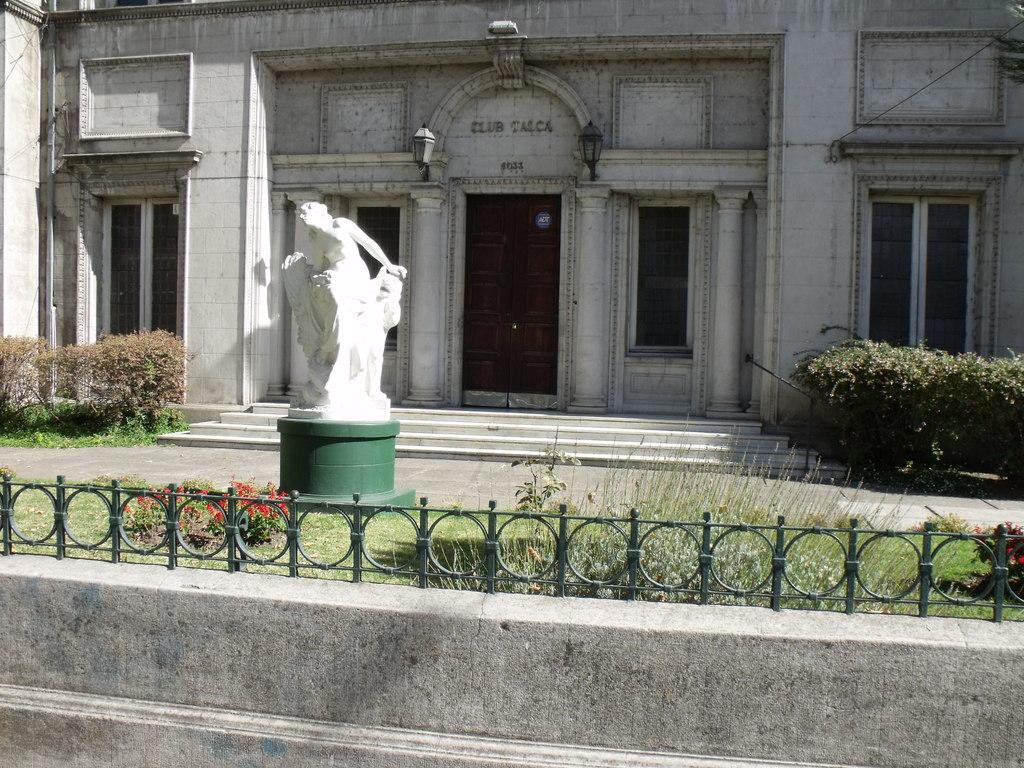What is the main object in the image? There is a statue in the image. What type of building is visible in the image? There is a house in the image. What features can be seen on the house? The house has a door and windows. What type of vegetation is present in the image? There are plants and flowers in the image. What structures can be seen in the image besides the house? There is a wall and a railing in the image. How many times does the flower hate the statue in the image? There is no indication of any emotions or interactions between the flower and the statue in the image. 